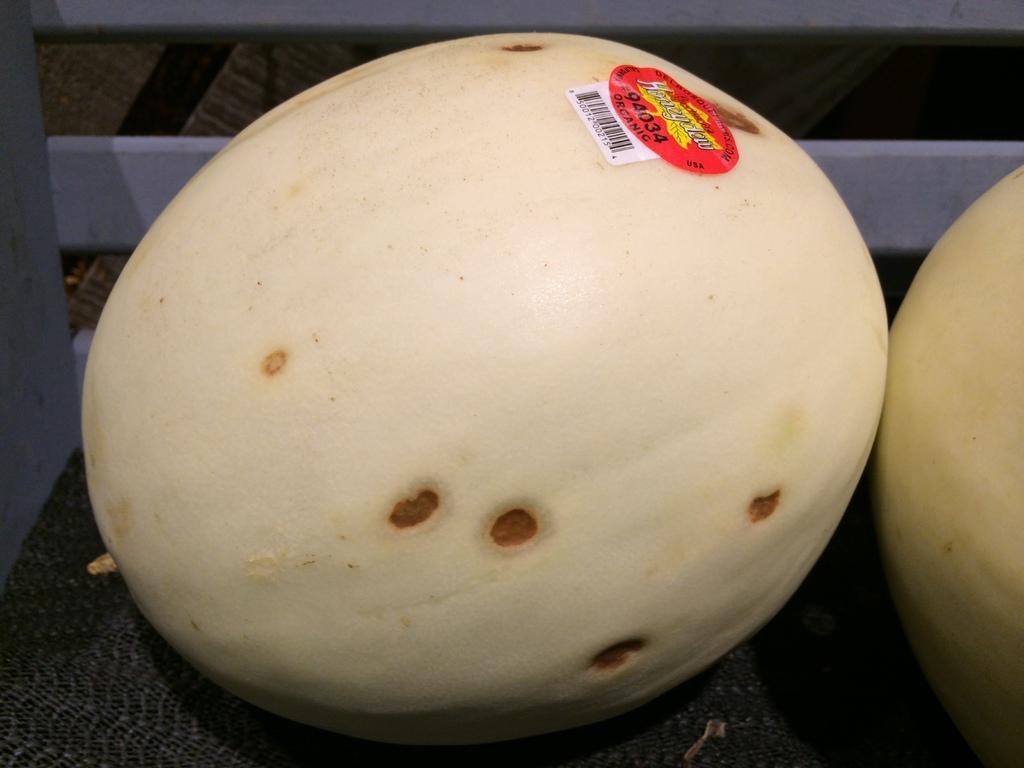In one or two sentences, can you explain what this image depicts? In this image I can see the cream colored pumpkins on the black color mat. I can see the red color sticker to one of the pumpkin. To the left I can see the wall. 